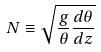Convert formula to latex. <formula><loc_0><loc_0><loc_500><loc_500>N \equiv \sqrt { \frac { g } { \theta } \frac { d \theta } { d z } }</formula> 